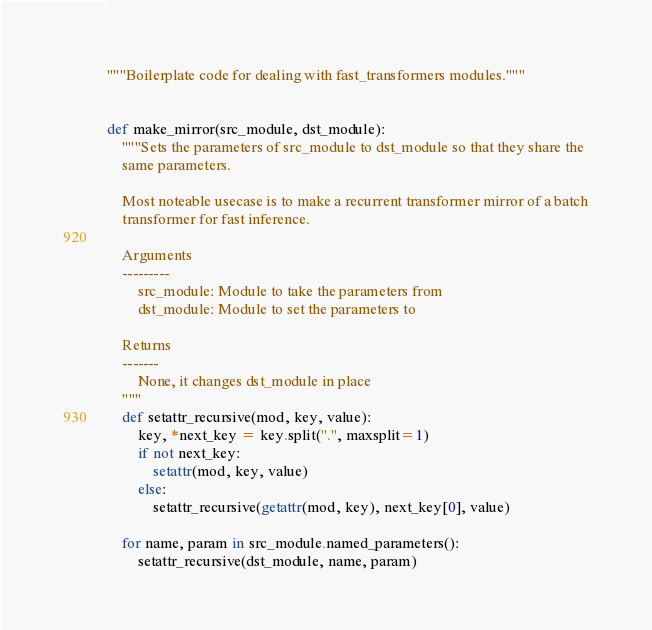<code> <loc_0><loc_0><loc_500><loc_500><_Python_>"""Boilerplate code for dealing with fast_transformers modules."""


def make_mirror(src_module, dst_module):
    """Sets the parameters of src_module to dst_module so that they share the
    same parameters.

    Most noteable usecase is to make a recurrent transformer mirror of a batch
    transformer for fast inference.

    Arguments
    ---------
        src_module: Module to take the parameters from
        dst_module: Module to set the parameters to

    Returns
    -------
        None, it changes dst_module in place
    """
    def setattr_recursive(mod, key, value):
        key, *next_key = key.split(".", maxsplit=1)
        if not next_key:
            setattr(mod, key, value)
        else:
            setattr_recursive(getattr(mod, key), next_key[0], value)

    for name, param in src_module.named_parameters():
        setattr_recursive(dst_module, name, param)
</code> 